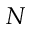Convert formula to latex. <formula><loc_0><loc_0><loc_500><loc_500>N</formula> 